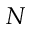Convert formula to latex. <formula><loc_0><loc_0><loc_500><loc_500>N</formula> 